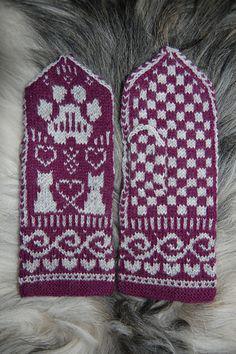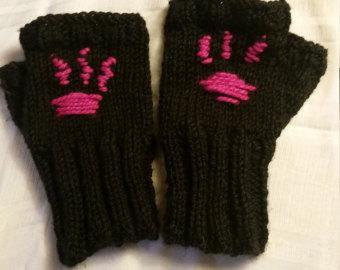The first image is the image on the left, the second image is the image on the right. For the images displayed, is the sentence "In 1 of the images, 2 gloves have thumbs pointing inward." factually correct? Answer yes or no. No. 